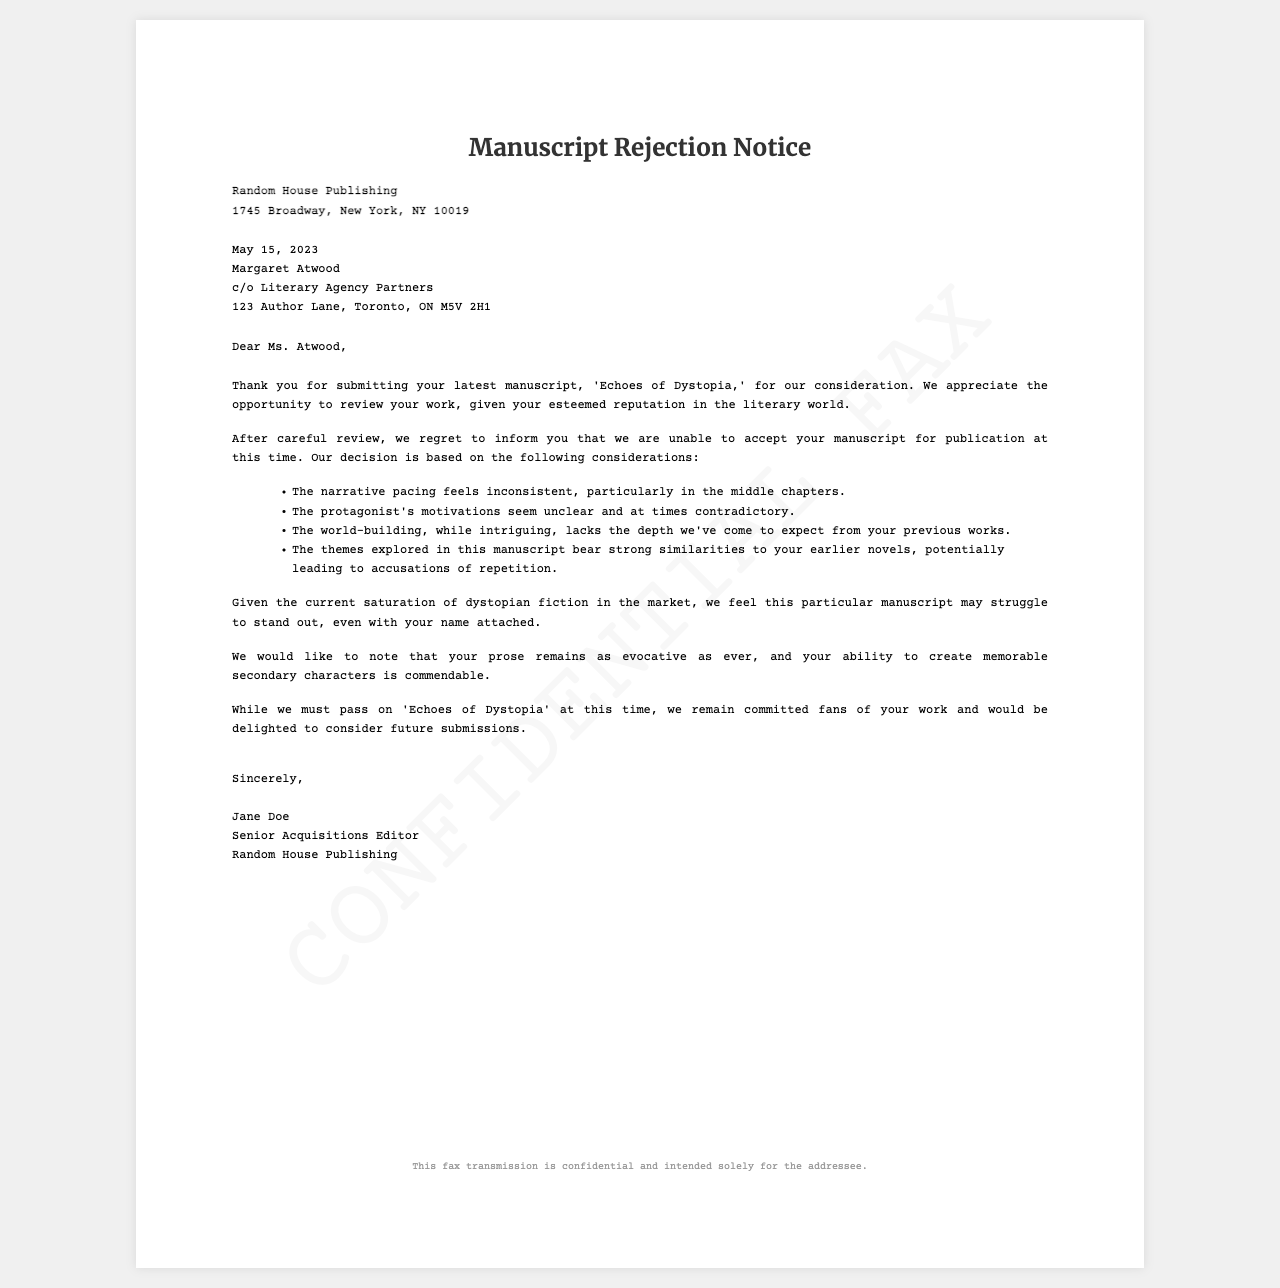What is the title of the manuscript? The title of the manuscript is mentioned in the opening paragraph of the fax.
Answer: Echoes of Dystopia Who is the recipient of the fax? The recipient's name is stated in the address section of the document.
Answer: Margaret Atwood What is the date of the fax? The date of the fax is located above the recipient's address in the document.
Answer: May 15, 2023 Who signed the rejection letter? The signature of the sender is provided in the closing section of the fax.
Answer: Jane Doe What is one specific criticism related to character motivations? The fax lists specific criticisms pertaining to the character aspects of the manuscript.
Answer: Protagonist's motivations seem unclear What does the publisher suggest about the saturation of the market? A statement in the fax discusses the current state of the market for similar manuscripts.
Answer: May struggle to stand out What is noted as commendable about the author's writing? Positive feedback is included in the document regarding the author's writing style.
Answer: Evocative prose In which city is Random House Publishing located? The address of the publisher is provided, indicating the city.
Answer: New York What is the document type? The specific nature of the document is indicated in the title at the top.
Answer: Manuscript Rejection Notice 